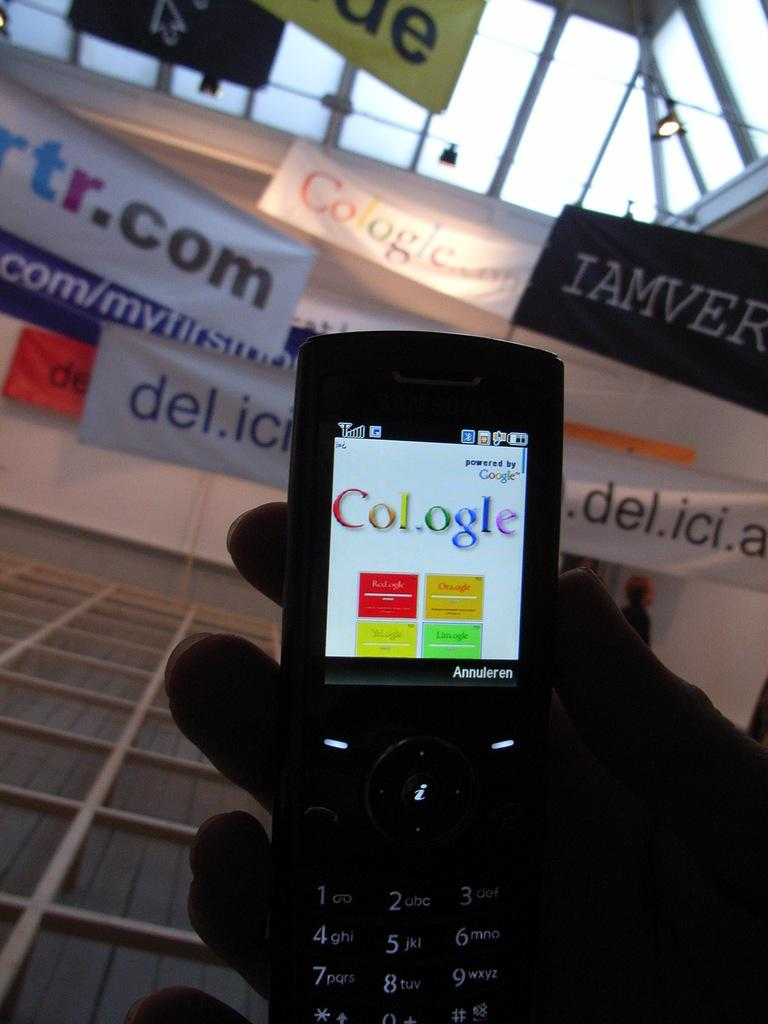<image>
Summarize the visual content of the image. a hand holding a cell phone with the screen showing text that reads cologle in different colors. 